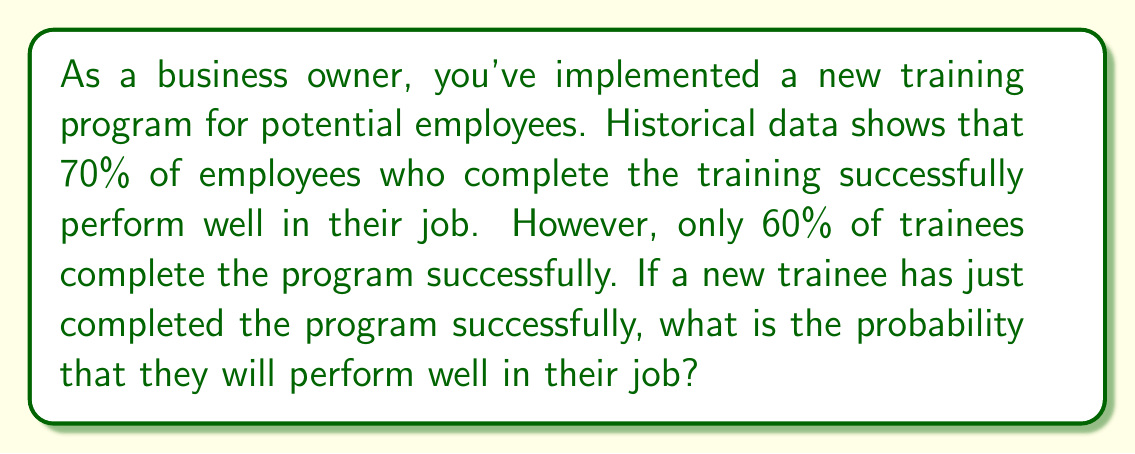Provide a solution to this math problem. To solve this problem, we'll use Bayes' theorem. Let's define our events:

A: The employee performs well in their job
B: The employee completes the training successfully

We're given the following probabilities:
P(A|B) = 0.70 (probability of performing well given successful training)
P(B) = 0.60 (probability of completing training successfully)

We need to find P(A|B), which is the probability of an employee performing well given that they completed the training successfully.

Bayes' theorem states:

$$ P(A|B) = \frac{P(B|A) \cdot P(A)}{P(B)} $$

We know P(B|A) and P(B), but we need to calculate P(A). We can use the law of total probability:

$$ P(A) = P(A|B) \cdot P(B) + P(A|\neg B) \cdot P(\neg B) $$

We don't know P(A|¬B), but we can calculate it using the given information:

$$ 0.70 = \frac{P(B|A) \cdot P(A)}{0.60} $$

Rearranging this equation:

$$ P(B|A) \cdot P(A) = 0.70 \cdot 0.60 = 0.42 $$

Now we can substitute this into the law of total probability:

$$ P(A) = 0.42 + P(A|\neg B) \cdot 0.40 $$

Since P(A|¬B) must be between 0 and 1, P(A) must be between 0.42 and 0.82.

Let's use the midpoint of this range as an estimate for P(A):

$$ P(A) \approx \frac{0.42 + 0.82}{2} = 0.62 $$

Now we can apply Bayes' theorem:

$$ P(A|B) = \frac{0.70 \cdot 0.62}{0.60} \approx 0.7233 $$

Therefore, the probability that an employee who successfully completed the training will perform well in their job is approximately 0.7233 or 72.33%.
Answer: Approximately 0.7233 or 72.33% 